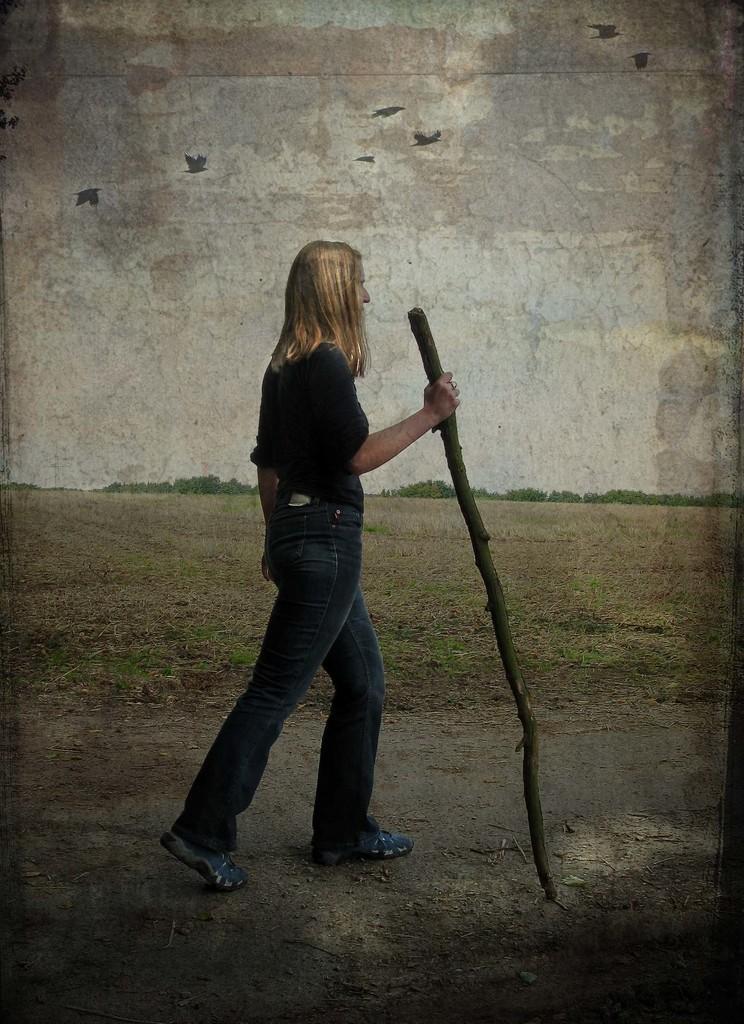How would you summarize this image in a sentence or two? In this image I can see a woman walking on the ground by holding a stick in the hand. In the background there are some trees. On the top of the image I can see the sky and also there are few birds are flying in the air. 